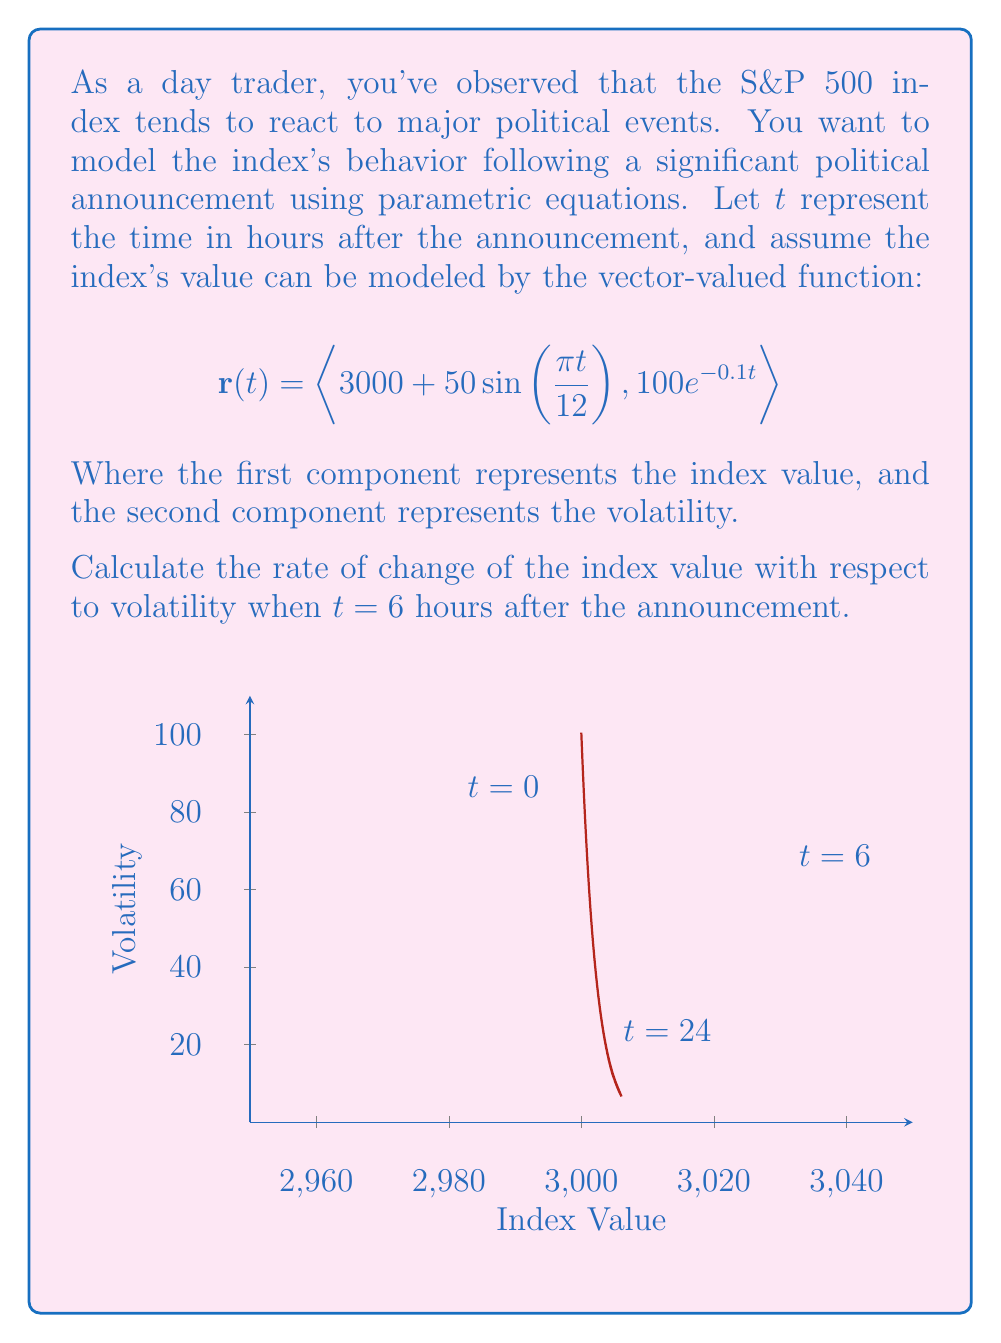Solve this math problem. To solve this problem, we'll follow these steps:

1) The rate of change of the index value with respect to volatility is given by $\frac{dx}{dy}$, where $x$ is the index value and $y$ is the volatility.

2) We can calculate this using the chain rule: $\frac{dx}{dy} = \frac{dx/dt}{dy/dt}$

3) Let's calculate $\frac{dx}{dt}$ and $\frac{dy}{dt}$:

   $\frac{dx}{dt} = 50\cos(\frac{\pi t}{12}) \cdot \frac{\pi}{12}$
   
   $\frac{dy}{dt} = -10e^{-0.1t}$

4) Now, we can form our expression for $\frac{dx}{dy}$:

   $\frac{dx}{dy} = \frac{50\cos(\frac{\pi t}{12}) \cdot \frac{\pi}{12}}{-10e^{-0.1t}}$

5) We need to evaluate this at $t = 6$. Let's substitute:

   $\frac{dx}{dy}\Big|_{t=6} = \frac{50\cos(\frac{\pi \cdot 6}{12}) \cdot \frac{\pi}{12}}{-10e^{-0.1 \cdot 6}}$

6) Simplify:
   
   $= \frac{50\cos(\frac{\pi}{2}) \cdot \frac{\pi}{12}}{-10e^{-0.6}}$
   
   $= \frac{0 \cdot \frac{\pi}{12}}{-10e^{-0.6}} = 0$

Therefore, the rate of change of the index value with respect to volatility at $t = 6$ hours is 0.
Answer: 0 